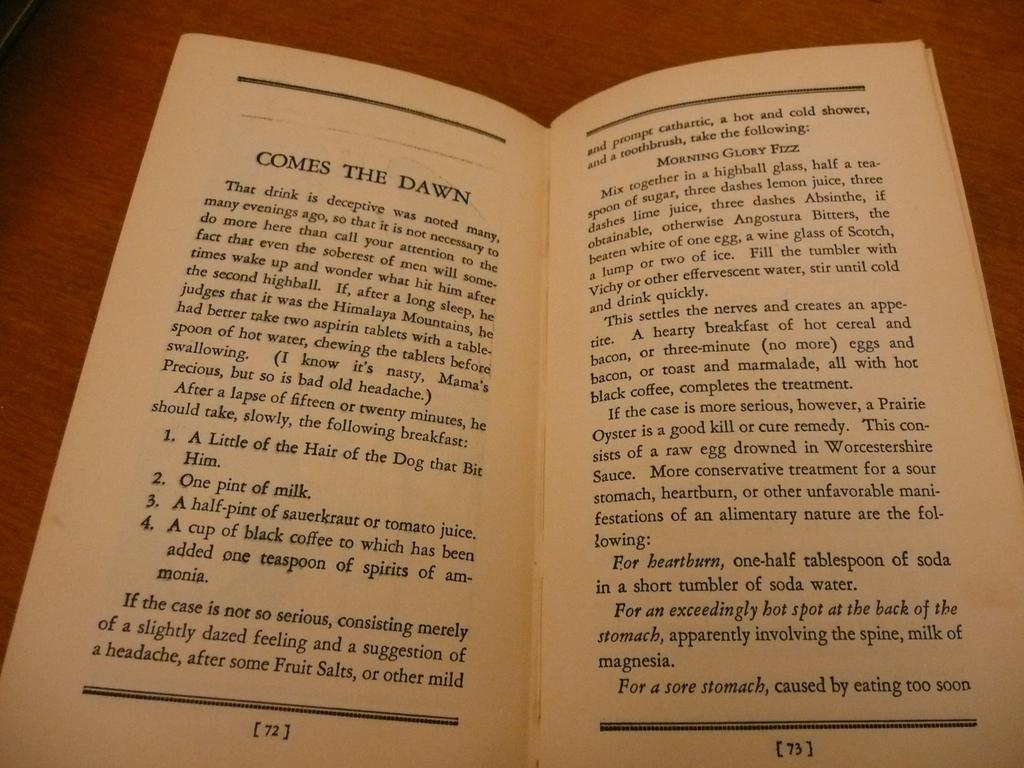<image>
Create a compact narrative representing the image presented. A book that has it's pages open describing various homemade remedies 